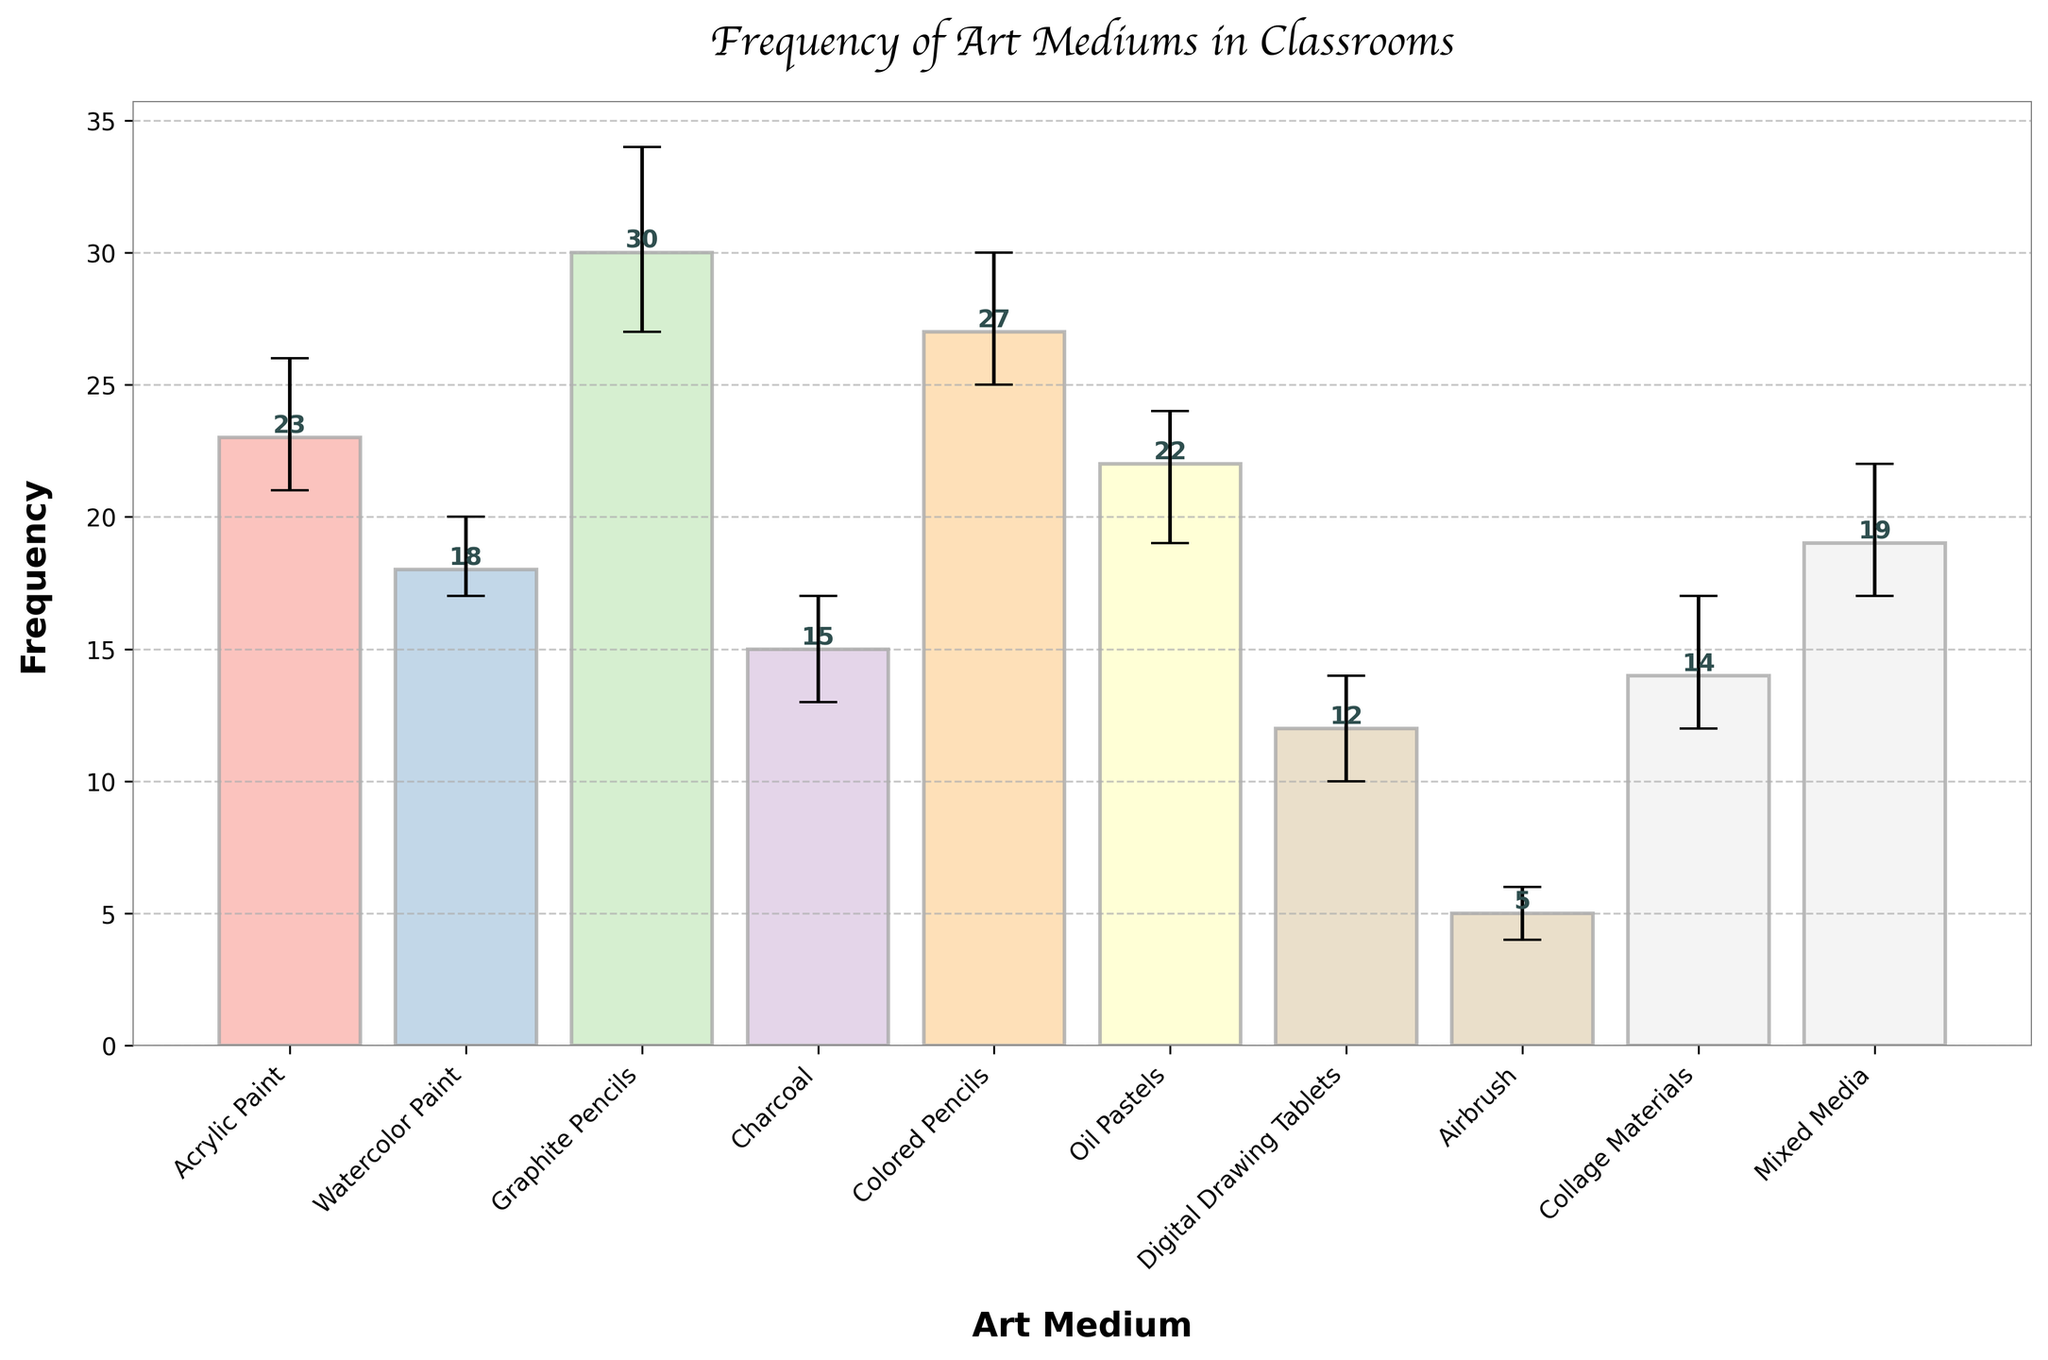What is the title of the bar chart? The title of the bar chart is displayed at the top and reads "Frequency of Art Mediums in Classrooms."
Answer: Frequency of Art Mediums in Classrooms What is the most frequently used art medium in the classroom? By looking at the height of the bars, Graphite Pencils has the highest bar, indicating it is the most frequently used medium.
Answer: Graphite Pencils Which art medium has the widest uncertainty range? To find the widest uncertainty range, we look at the lengths of the error bars. Graphite Pencils has the largest uncertainty range with lengths of 3 and 4, summing to a total range of 7.
Answer: Graphite Pencils What is the total frequency of Acrylic Paint and Watercolor Paint combined? We add the frequencies of Acrylic Paint (23) and Watercolor Paint (18) to get the total frequency.
Answer: 41 By how much does the frequency of Digital Drawing Tablets differ from Oil Pastels? Subtract the frequency of Digital Drawing Tablets (12) from Oil Pastels (22) to find the difference.
Answer: 10 Which two art mediums have the closest frequencies? By examining the heights of bars, Oil Pastels (22) and Acrylic Paint (23) are closest in frequency.
Answer: Oil Pastels and Acrylic Paints What is the sum of the frequencies of all the art mediums? We sum the frequencies of all the art mediums: 23 + 18 + 30 + 15 + 27 + 22 + 12 + 5 + 14 + 19. This adds up to 185.
Answer: 185 Which art medium has the smallest frequency? By looking at the shortest bar, Airbrush has the smallest frequency with a value of 5.
Answer: Airbrush What is the average frequency of the art mediums? To find the average, sum all the frequencies (185 from the previous calculation) and divide by the number of art mediums (10). The average is 18.5.
Answer: 18.5 What is the range of frequencies for Colored Pencils? Examining the error bars for Colored Pencils, the lower uncertainty is 2 and the upper uncertainty is 3, giving a range of 2 to 30.
Answer: 25 to 30 